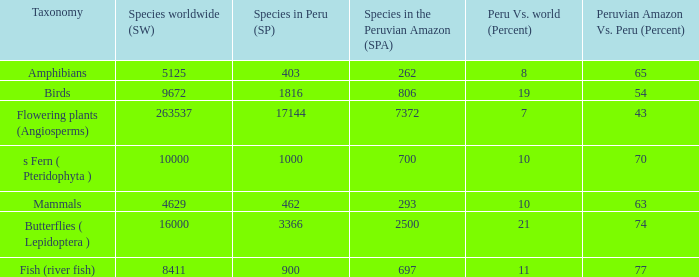What's the minimum species in the peruvian amazon with taxonomy s fern ( pteridophyta ) 700.0. 